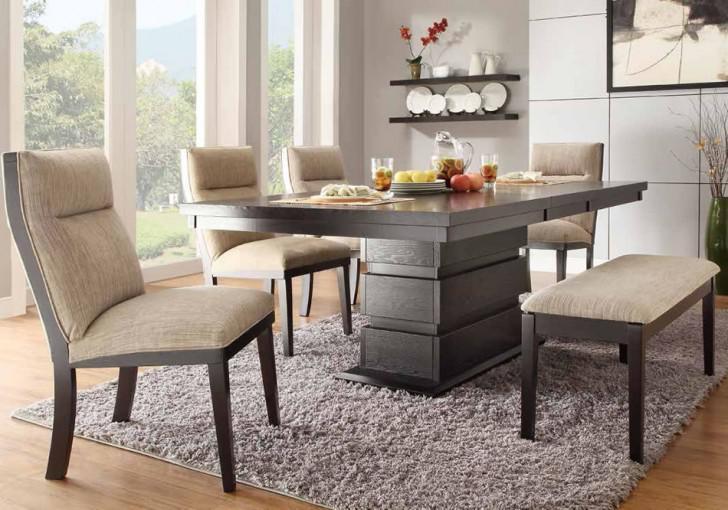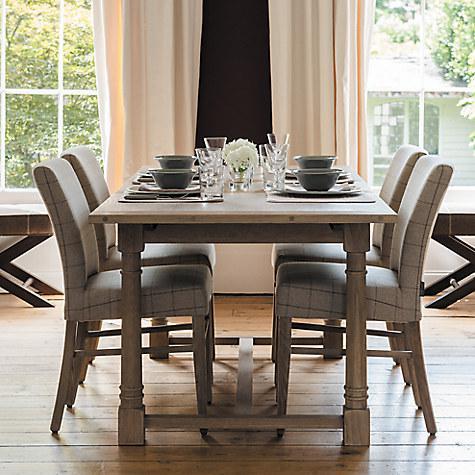The first image is the image on the left, the second image is the image on the right. For the images displayed, is the sentence "In one image, a rectangular table has long bench seating on one side." factually correct? Answer yes or no. Yes. 